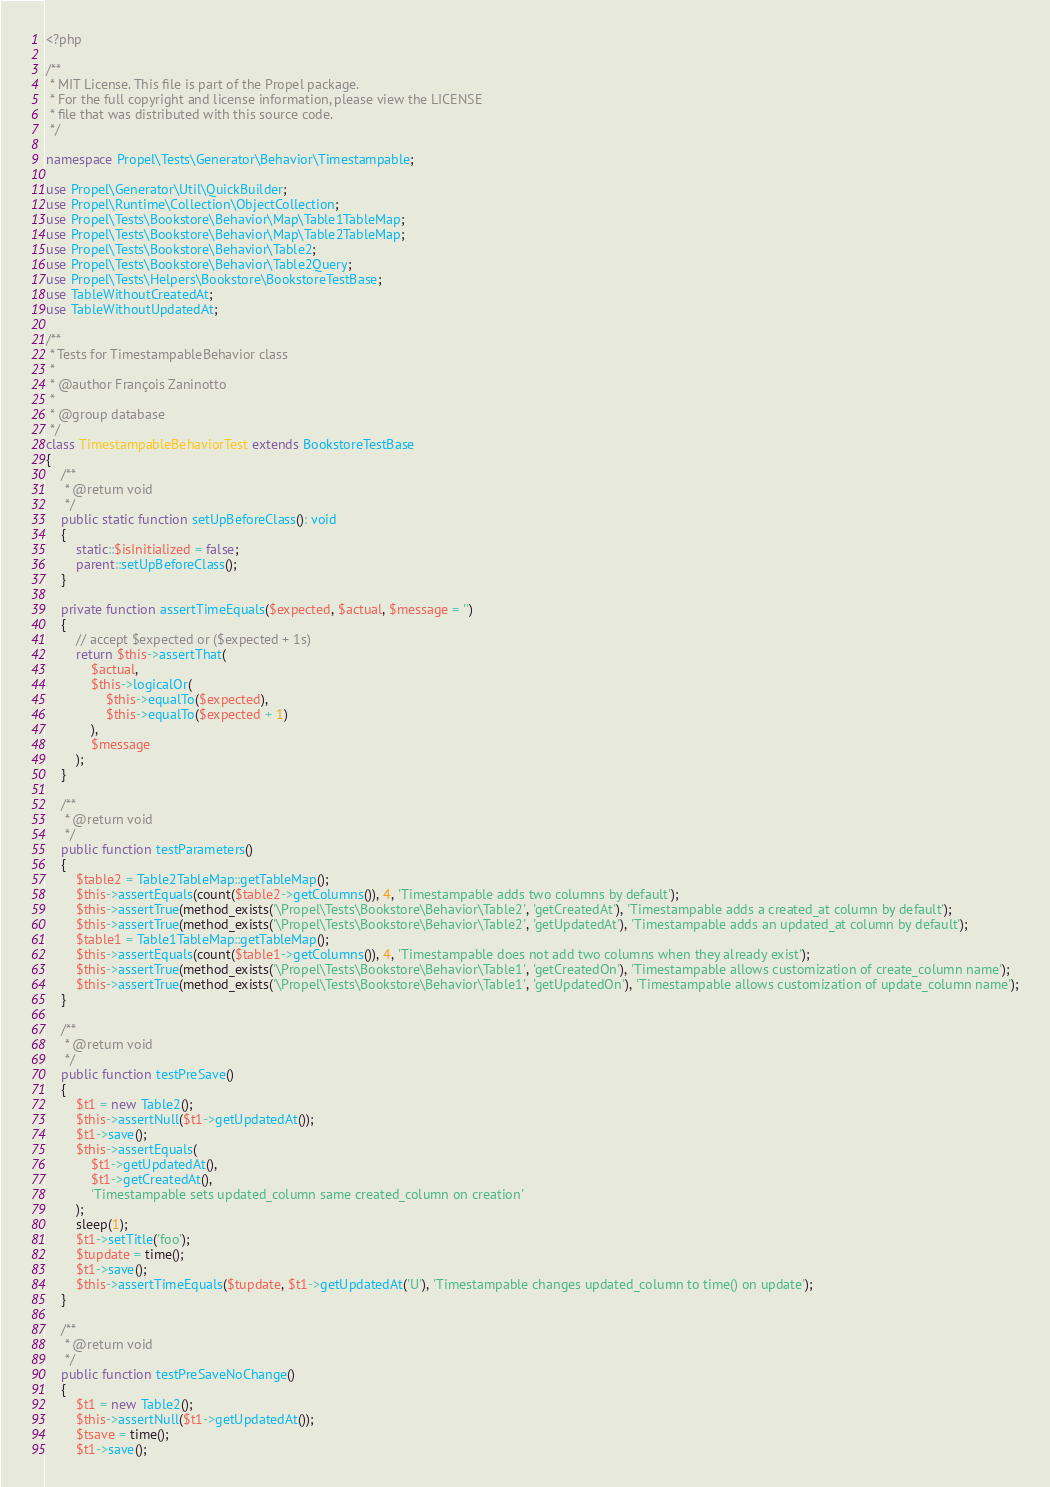<code> <loc_0><loc_0><loc_500><loc_500><_PHP_><?php

/**
 * MIT License. This file is part of the Propel package.
 * For the full copyright and license information, please view the LICENSE
 * file that was distributed with this source code.
 */

namespace Propel\Tests\Generator\Behavior\Timestampable;

use Propel\Generator\Util\QuickBuilder;
use Propel\Runtime\Collection\ObjectCollection;
use Propel\Tests\Bookstore\Behavior\Map\Table1TableMap;
use Propel\Tests\Bookstore\Behavior\Map\Table2TableMap;
use Propel\Tests\Bookstore\Behavior\Table2;
use Propel\Tests\Bookstore\Behavior\Table2Query;
use Propel\Tests\Helpers\Bookstore\BookstoreTestBase;
use TableWithoutCreatedAt;
use TableWithoutUpdatedAt;

/**
 * Tests for TimestampableBehavior class
 *
 * @author François Zaninotto
 *
 * @group database
 */
class TimestampableBehaviorTest extends BookstoreTestBase
{
    /**
     * @return void
     */
    public static function setUpBeforeClass(): void
    {
        static::$isInitialized = false;
        parent::setUpBeforeClass();
    }

    private function assertTimeEquals($expected, $actual, $message = '')
    {
        // accept $expected or ($expected + 1s)
        return $this->assertThat(
            $actual,
            $this->logicalOr(
                $this->equalTo($expected),
                $this->equalTo($expected + 1)
            ),
            $message
        );
    }

    /**
     * @return void
     */
    public function testParameters()
    {
        $table2 = Table2TableMap::getTableMap();
        $this->assertEquals(count($table2->getColumns()), 4, 'Timestampable adds two columns by default');
        $this->assertTrue(method_exists('\Propel\Tests\Bookstore\Behavior\Table2', 'getCreatedAt'), 'Timestampable adds a created_at column by default');
        $this->assertTrue(method_exists('\Propel\Tests\Bookstore\Behavior\Table2', 'getUpdatedAt'), 'Timestampable adds an updated_at column by default');
        $table1 = Table1TableMap::getTableMap();
        $this->assertEquals(count($table1->getColumns()), 4, 'Timestampable does not add two columns when they already exist');
        $this->assertTrue(method_exists('\Propel\Tests\Bookstore\Behavior\Table1', 'getCreatedOn'), 'Timestampable allows customization of create_column name');
        $this->assertTrue(method_exists('\Propel\Tests\Bookstore\Behavior\Table1', 'getUpdatedOn'), 'Timestampable allows customization of update_column name');
    }

    /**
     * @return void
     */
    public function testPreSave()
    {
        $t1 = new Table2();
        $this->assertNull($t1->getUpdatedAt());
        $t1->save();
        $this->assertEquals(
            $t1->getUpdatedAt(),
            $t1->getCreatedAt(),
            'Timestampable sets updated_column same created_column on creation'
        );
        sleep(1);
        $t1->setTitle('foo');
        $tupdate = time();
        $t1->save();
        $this->assertTimeEquals($tupdate, $t1->getUpdatedAt('U'), 'Timestampable changes updated_column to time() on update');
    }

    /**
     * @return void
     */
    public function testPreSaveNoChange()
    {
        $t1 = new Table2();
        $this->assertNull($t1->getUpdatedAt());
        $tsave = time();
        $t1->save();</code> 